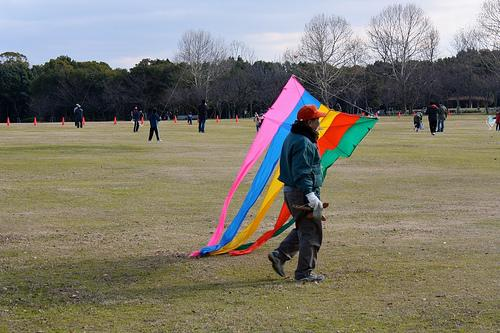Which color of the rainbow is missing from this kite? orange 